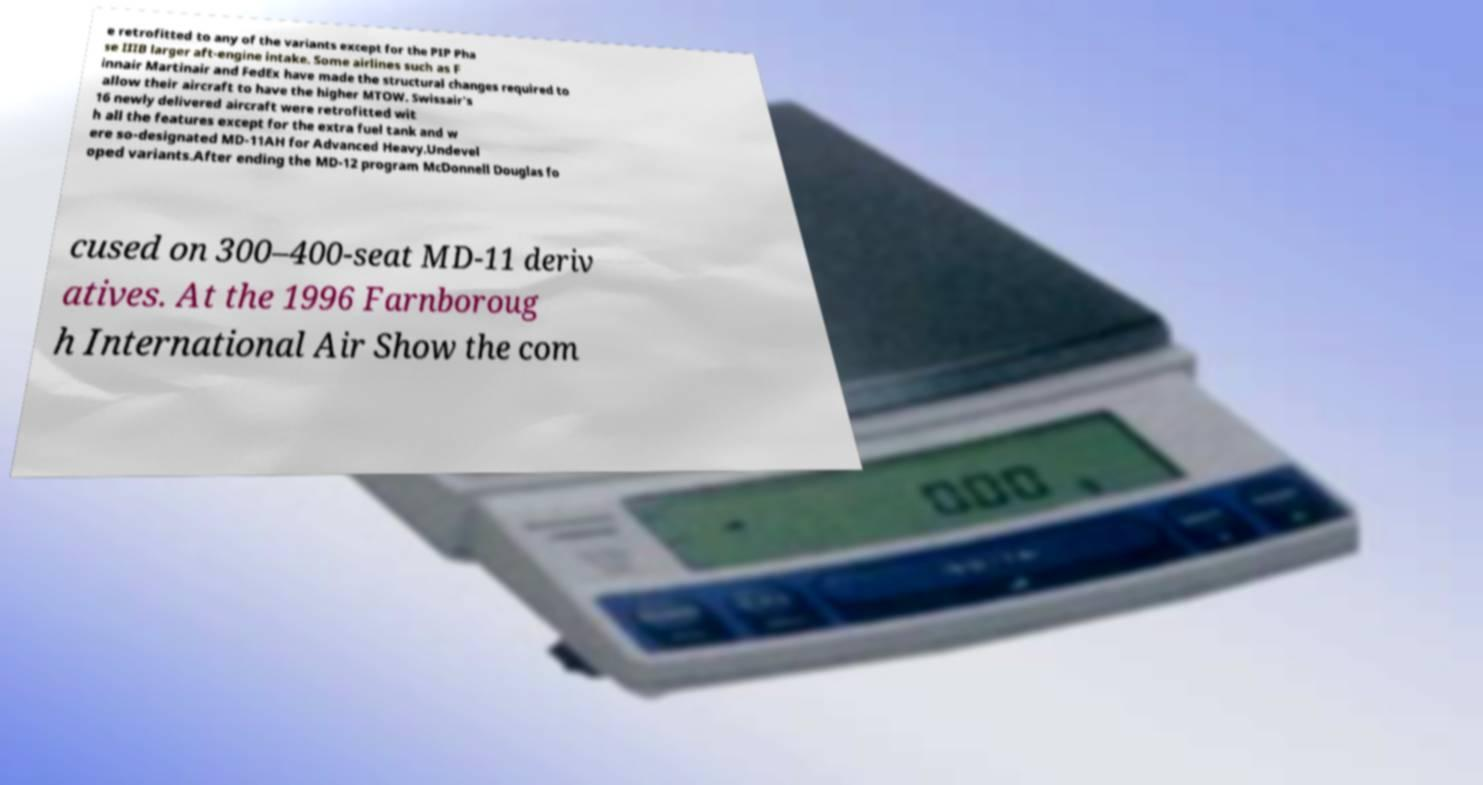I need the written content from this picture converted into text. Can you do that? e retrofitted to any of the variants except for the PIP Pha se IIIB larger aft-engine intake. Some airlines such as F innair Martinair and FedEx have made the structural changes required to allow their aircraft to have the higher MTOW. Swissair's 16 newly delivered aircraft were retrofitted wit h all the features except for the extra fuel tank and w ere so-designated MD-11AH for Advanced Heavy.Undevel oped variants.After ending the MD-12 program McDonnell Douglas fo cused on 300–400-seat MD-11 deriv atives. At the 1996 Farnboroug h International Air Show the com 